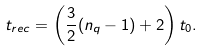<formula> <loc_0><loc_0><loc_500><loc_500>t _ { r e c } = \left ( \frac { 3 } { 2 } ( n _ { q } - 1 ) + 2 \right ) t _ { 0 } .</formula> 